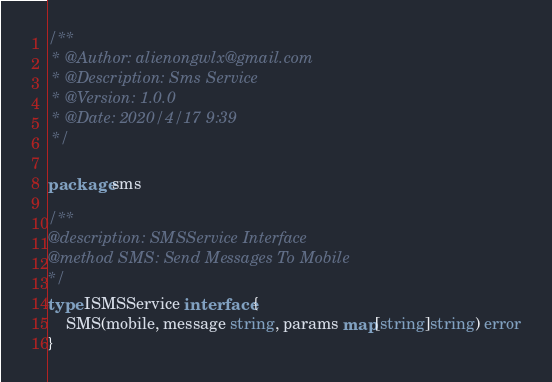Convert code to text. <code><loc_0><loc_0><loc_500><loc_500><_Go_>/**
 * @Author: alienongwlx@gmail.com
 * @Description: Sms Service
 * @Version: 1.0.0
 * @Date: 2020/4/17 9:39
 */

package sms

/**
@description: SMSService Interface
@method SMS: Send Messages To Mobile
*/
type ISMSService interface {
	SMS(mobile, message string, params map[string]string) error
}
</code> 